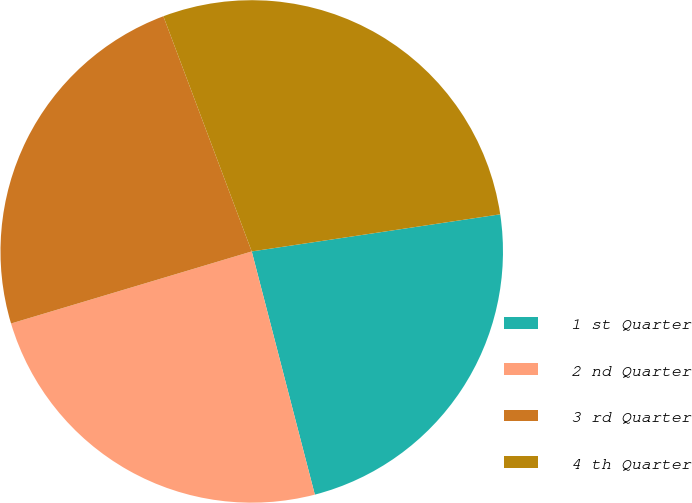Convert chart to OTSL. <chart><loc_0><loc_0><loc_500><loc_500><pie_chart><fcel>1 st Quarter<fcel>2 nd Quarter<fcel>3 rd Quarter<fcel>4 th Quarter<nl><fcel>23.32%<fcel>24.41%<fcel>23.91%<fcel>28.36%<nl></chart> 